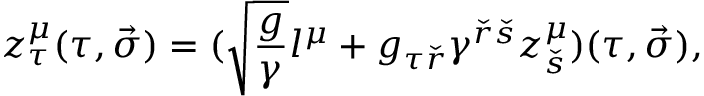<formula> <loc_0><loc_0><loc_500><loc_500>z _ { \tau } ^ { \mu } ( \tau , \vec { \sigma } ) = ( \sqrt { { \frac { g } { \gamma } } } l ^ { \mu } + g _ { \tau { \check { r } } } \gamma ^ { { \check { r } } { \check { s } } } z _ { \check { s } } ^ { \mu } ) ( \tau , \vec { \sigma } ) ,</formula> 